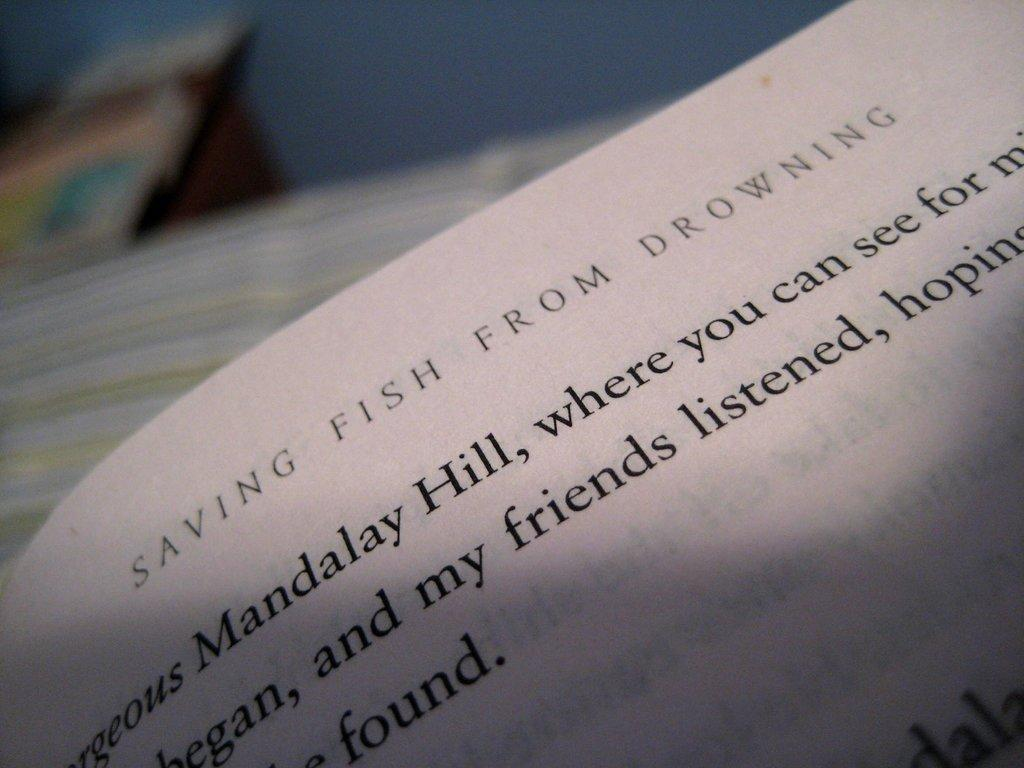<image>
Provide a brief description of the given image. Open page for the book Saving Fish From Drowning. 